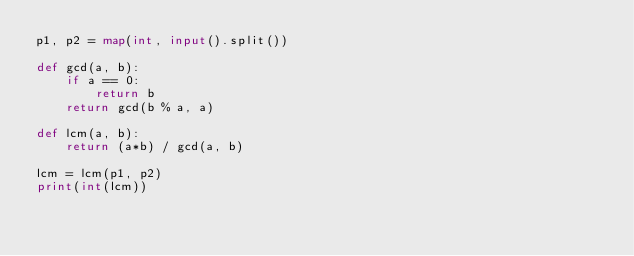Convert code to text. <code><loc_0><loc_0><loc_500><loc_500><_Python_>p1, p2 = map(int, input().split())

def gcd(a, b):
    if a == 0:
        return b
    return gcd(b % a, a)

def lcm(a, b):
    return (a*b) / gcd(a, b)

lcm = lcm(p1, p2)
print(int(lcm))</code> 